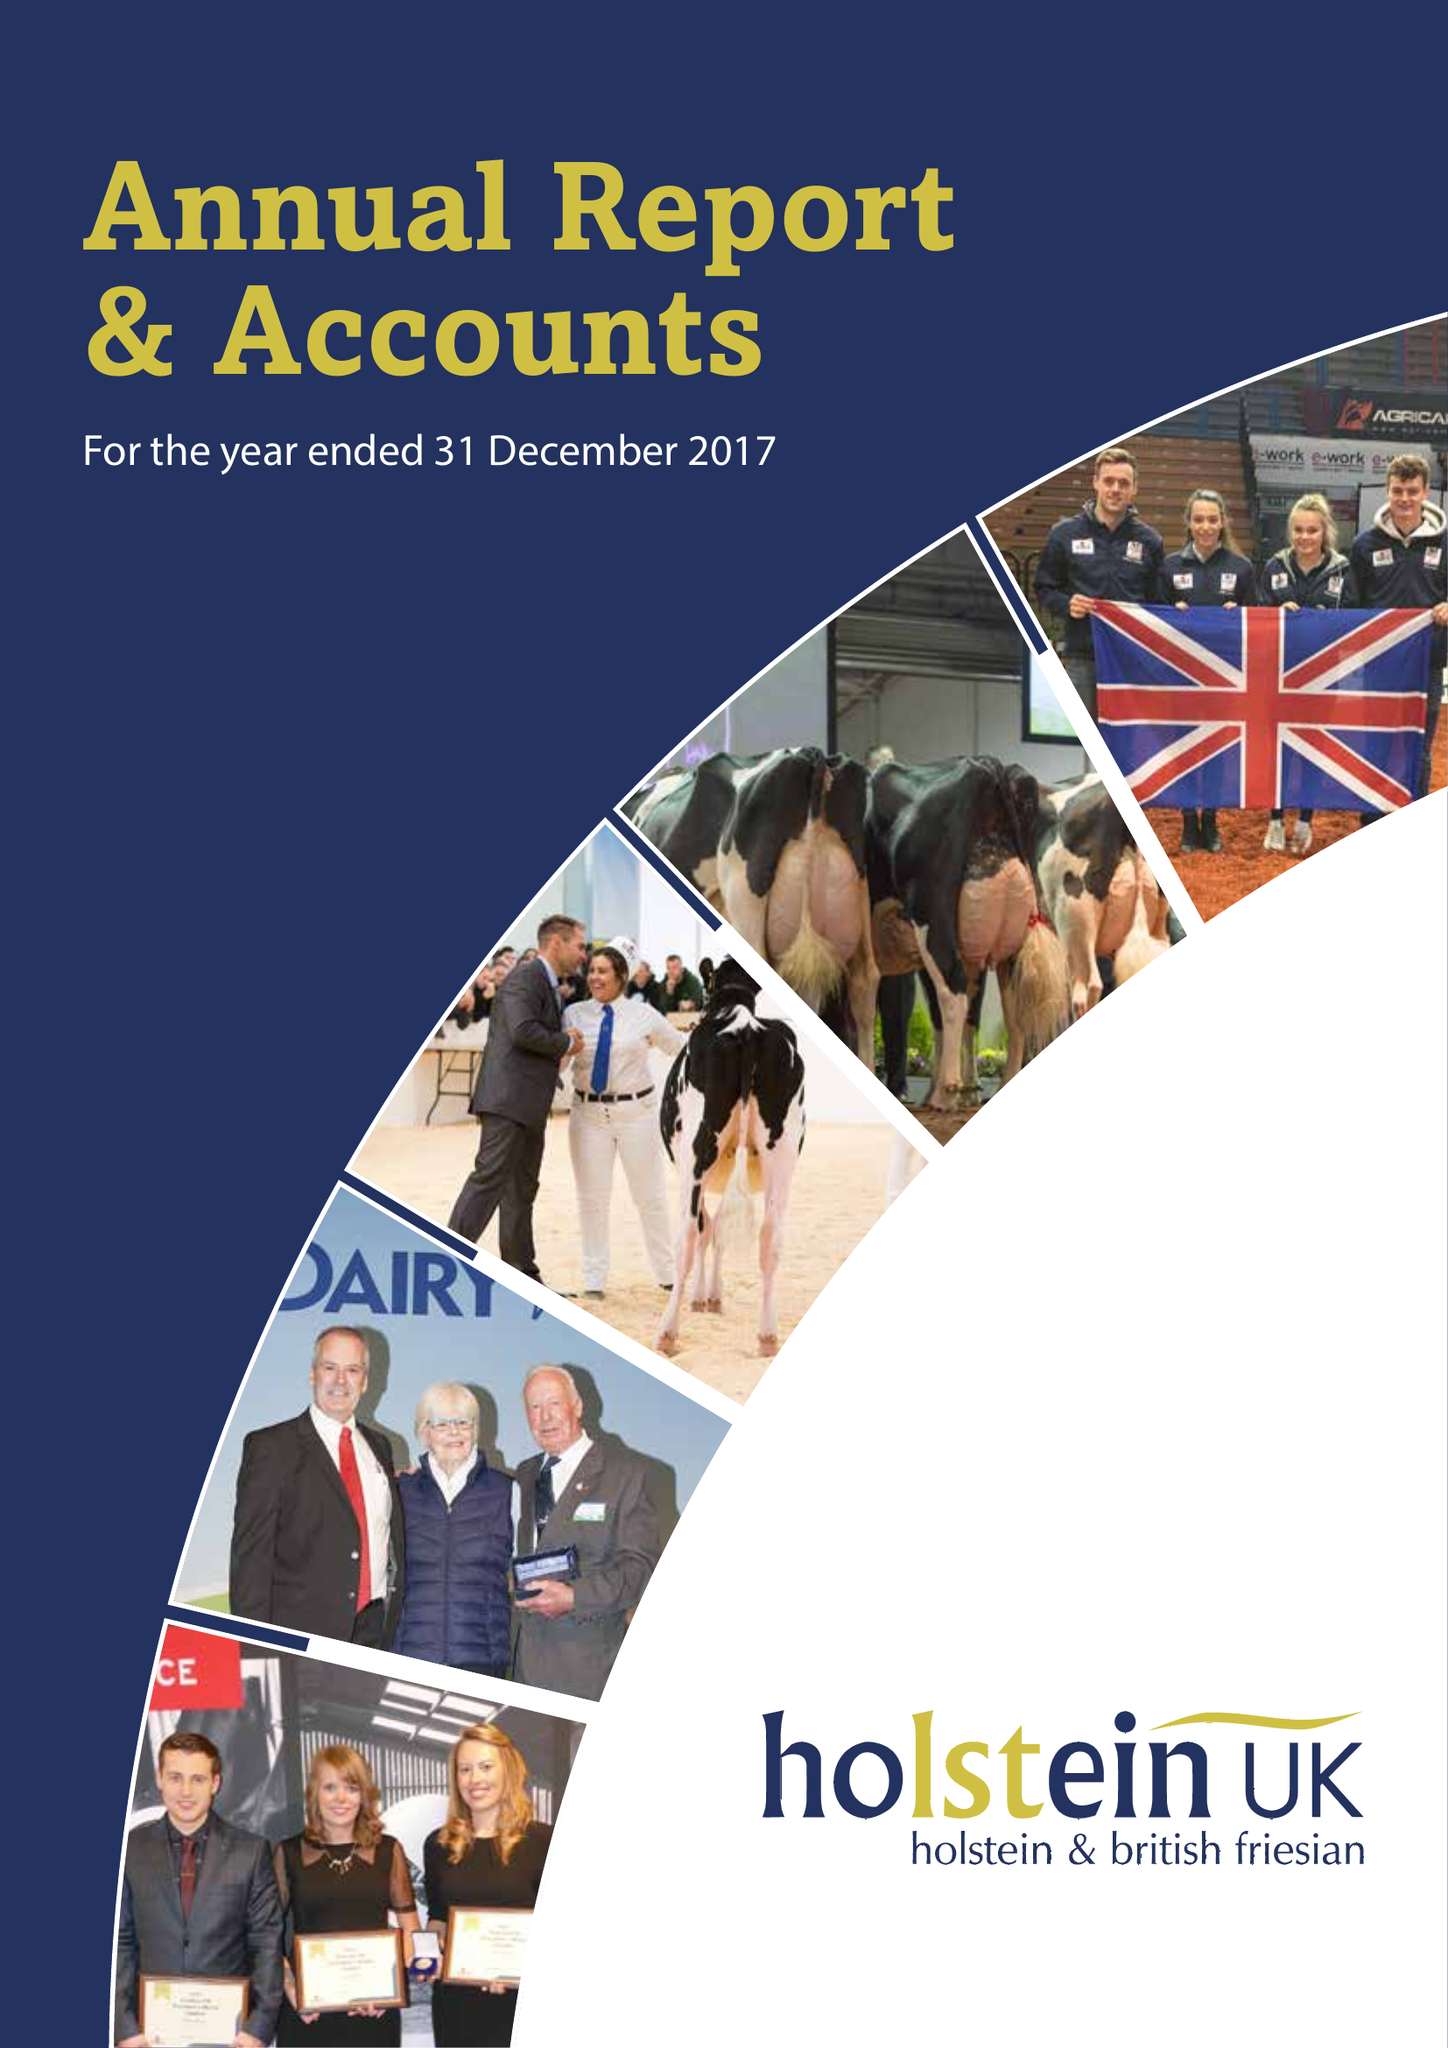What is the value for the charity_number?
Answer the question using a single word or phrase. 1072998 